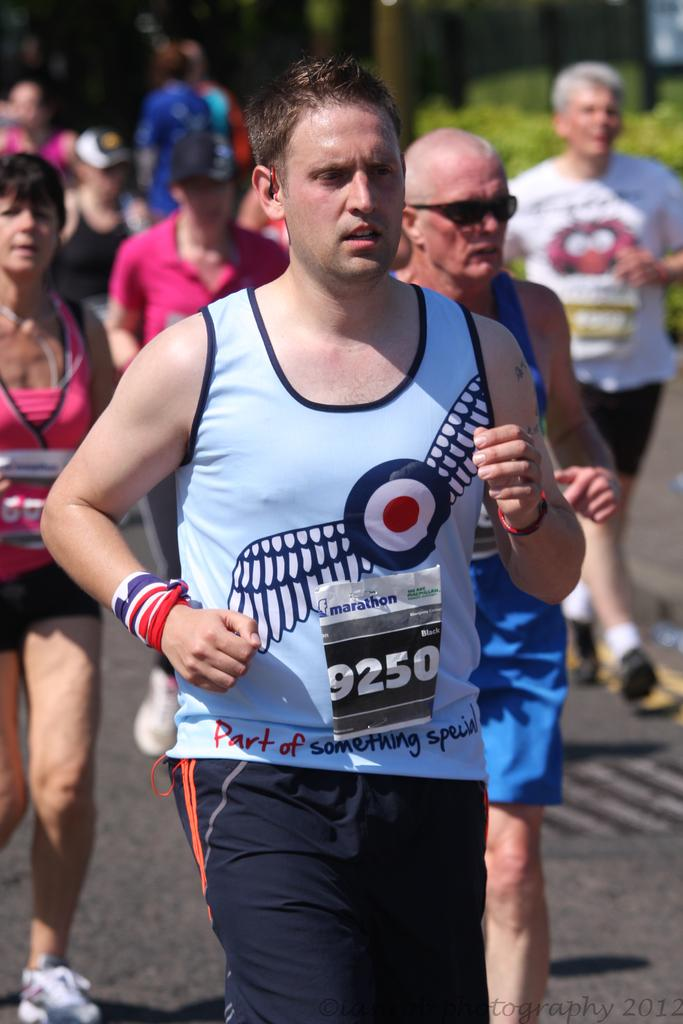What is the main subject of the image? The main subject of the image is a man running in the foreground. Where is the man running? The man is running on a road. Are there any other people running in the image? Yes, there are persons running in the background of the image. What can be seen in the background of the image? Greenery is visible in the background of the image. How would you describe the quality of the image? The top part of the image appears blurred. What type of voice can be heard coming from the cable in the image? There is no cable present in the image, and therefore no voice can be heard coming from it. 